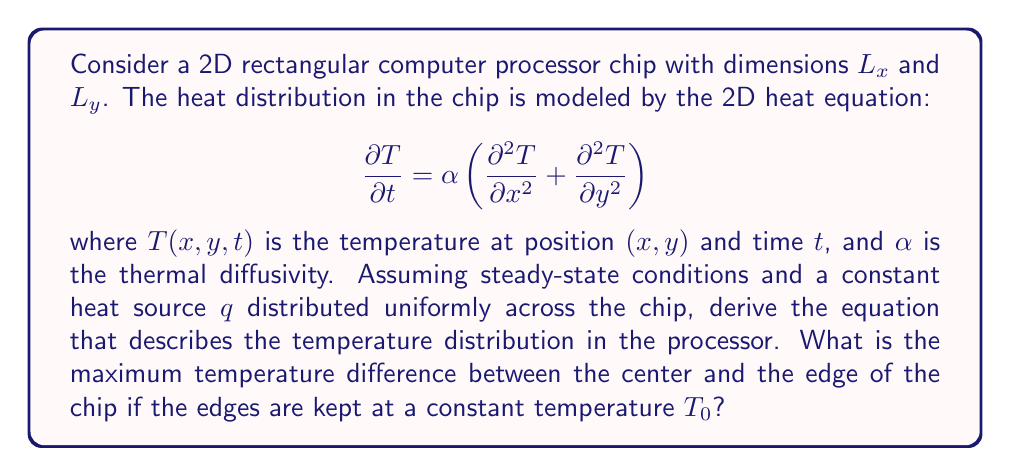Show me your answer to this math problem. Let's approach this step-by-step:

1) For steady-state conditions, $\frac{\partial T}{\partial t} = 0$. The heat equation becomes:

   $$0 = \alpha \left(\frac{\partial^2 T}{\partial x^2} + \frac{\partial^2 T}{\partial y^2}\right) + \frac{q}{k}$$

   where $k$ is the thermal conductivity and $q/k$ represents the heat source term.

2) Simplifying:

   $$\frac{\partial^2 T}{\partial x^2} + \frac{\partial^2 T}{\partial y^2} = -\frac{q}{k\alpha}$$

3) This is a Poisson equation. The general solution has the form:

   $$T(x,y) = -\frac{q}{4k\alpha}(x^2 + y^2) + Ax + By + C$$

   where $A$, $B$, and $C$ are constants determined by boundary conditions.

4) Given the symmetry of the problem, we can assume the maximum temperature is at the center $(x,y) = (L_x/2, L_y/2)$, and the minimum is at the edges.

5) Applying the boundary conditions:
   $T(0,y) = T(L_x,y) = T(x,0) = T(x,L_y) = T_0$

6) Solving for the constants, we get:

   $$T(x,y) = T_0 + \frac{q}{4k\alpha}(L_x^2 + L_y^2) - \frac{q}{4k\alpha}(x^2 + y^2)$$

7) The maximum temperature difference is:

   $$\Delta T_{max} = T(L_x/2, L_y/2) - T_0 = \frac{q}{16k\alpha}(L_x^2 + L_y^2)$$
Answer: $\Delta T_{max} = \frac{q}{16k\alpha}(L_x^2 + L_y^2)$ 